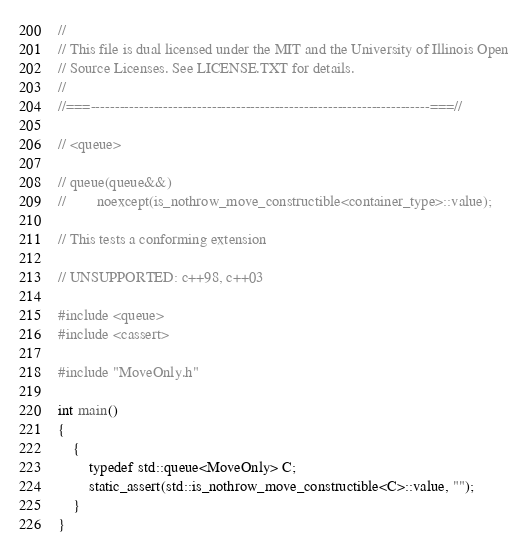Convert code to text. <code><loc_0><loc_0><loc_500><loc_500><_C++_>//
// This file is dual licensed under the MIT and the University of Illinois Open
// Source Licenses. See LICENSE.TXT for details.
//
//===----------------------------------------------------------------------===//

// <queue>

// queue(queue&&)
//        noexcept(is_nothrow_move_constructible<container_type>::value);

// This tests a conforming extension

// UNSUPPORTED: c++98, c++03

#include <queue>
#include <cassert>

#include "MoveOnly.h"

int main()
{
    {
        typedef std::queue<MoveOnly> C;
        static_assert(std::is_nothrow_move_constructible<C>::value, "");
    }
}
</code> 